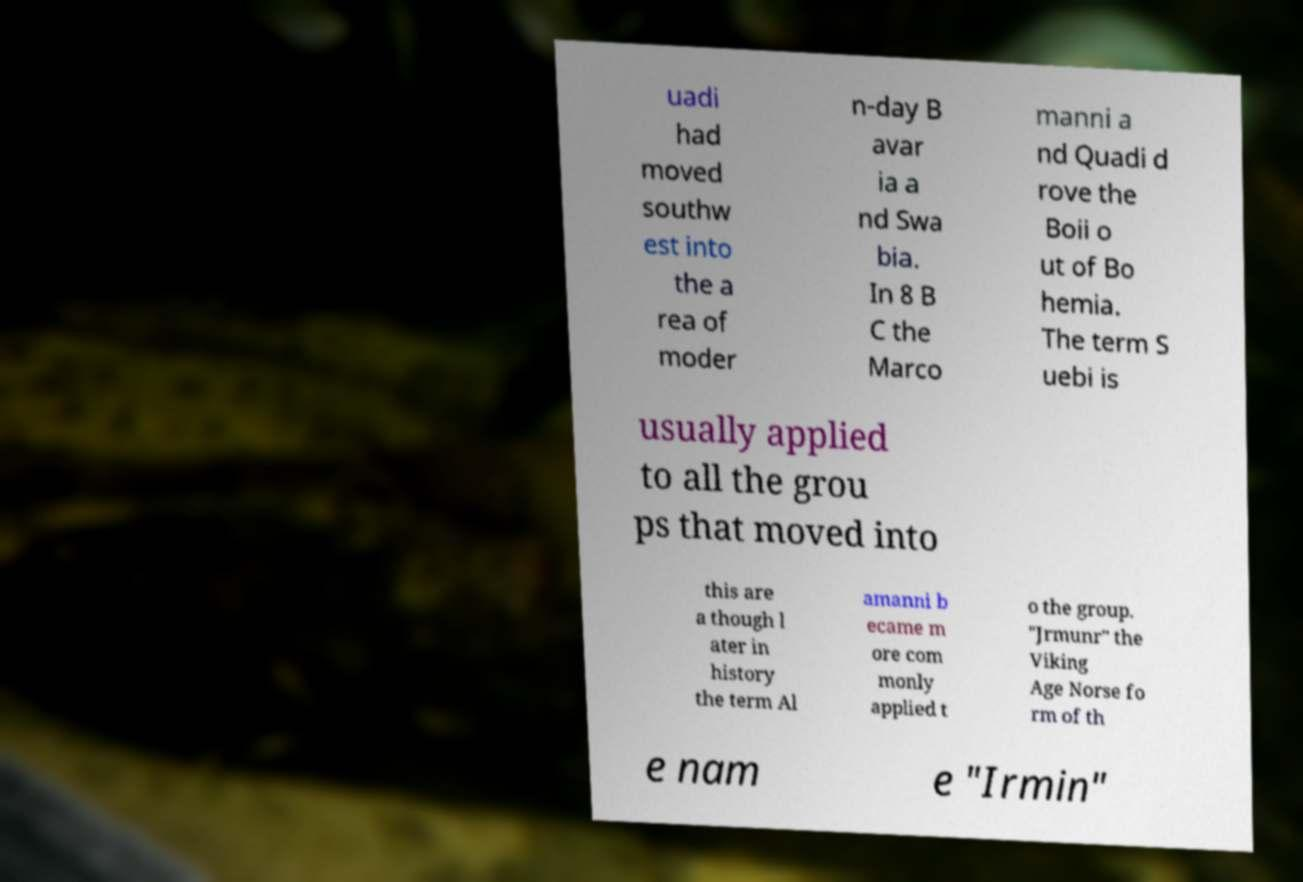Could you extract and type out the text from this image? uadi had moved southw est into the a rea of moder n-day B avar ia a nd Swa bia. In 8 B C the Marco manni a nd Quadi d rove the Boii o ut of Bo hemia. The term S uebi is usually applied to all the grou ps that moved into this are a though l ater in history the term Al amanni b ecame m ore com monly applied t o the group. "Jrmunr" the Viking Age Norse fo rm of th e nam e "Irmin" 